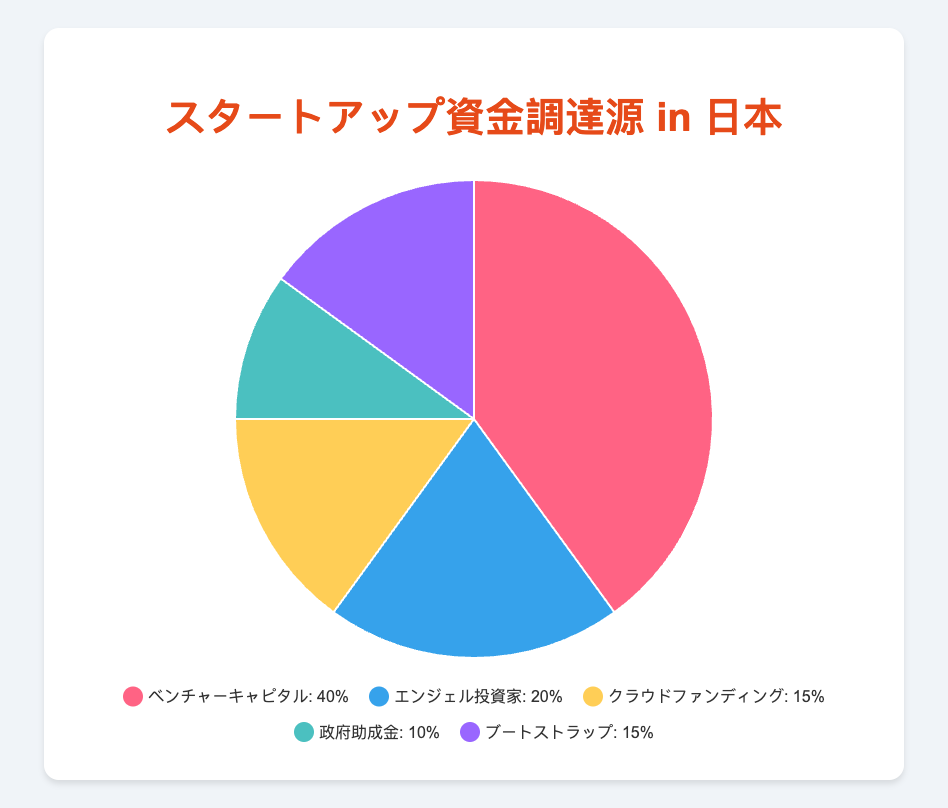Which funding source has the highest percentage? By looking at the pie chart, the segment labeled 'ベンチャーキャピタル' (Venture Capital) takes up the largest portion of the chart. This indicates that Venture Capital has the highest percentage of funding sources.
Answer: Venture Capital Which funding source has the smallest percentage? Inspecting the pie chart, the smallest segment is labeled '政府助成金' (Government Grants), occupying the least space.
Answer: Government Grants What is the combined percentage of Crowdfunding and Bootstrapping? Crowdfunding is 15% and Bootstrapping is also 15%. Adding these two percentages together gives us 15% + 15% = 30%.
Answer: 30% How does the percentage of Angel Investors compare to Government Grants? Angel Investors account for 20%, while Government Grants account for 10%. Therefore, Angel Investors have a greater percentage by 20% - 10% = 10%.
Answer: Angel Investors have a 10% higher percentage If we combine the percentages of all three entities with the lowest percentages, what is the total? The percentages for Crowdfunding, Government Grants, and Bootstrapping are 15%, 10%, and 15% respectively. Adding these gives 15% + 10% + 15% = 40%.
Answer: 40% Which color in the chart represents Bootstrapping, and what is its percentage? The segment representing Bootstrapping is colored purple, and its percentage is 15%.
Answer: Purple, 15% Compare the sum of the percentages of Angel Investors and Bootstrapping with the percentage of Venture Capital. Which is higher? Angel Investors have 20% and Bootstrapping has 15%, adding these gives 35%. Venture Capital is 40%. Therefore, Venture Capital is higher by 40% - 35% = 5%.
Answer: Venture Capital is higher by 5% What is the difference between the highest and lowest percentages? The highest percentage is Venture Capital at 40% and the lowest is Government Grants at 10%. The difference is 40% - 10% = 30%.
Answer: 30% Which funding source is associated with a turquoise-colored segment, and what is its percentage? The turquoise-colored segment corresponds to '政府助成金' (Government Grants) with a percentage of 10%.
Answer: Government Grants, 10% What is the total percentage of non-institutional funding sources (Crowdfunding and Bootstrapping combined)? Crowdfunding and Bootstrapping both represent non-institutional funding sources. Crowdfunding is 15% and Bootstrapping is 15%. Adding these together gives us 15% + 15% = 30%.
Answer: 30% 